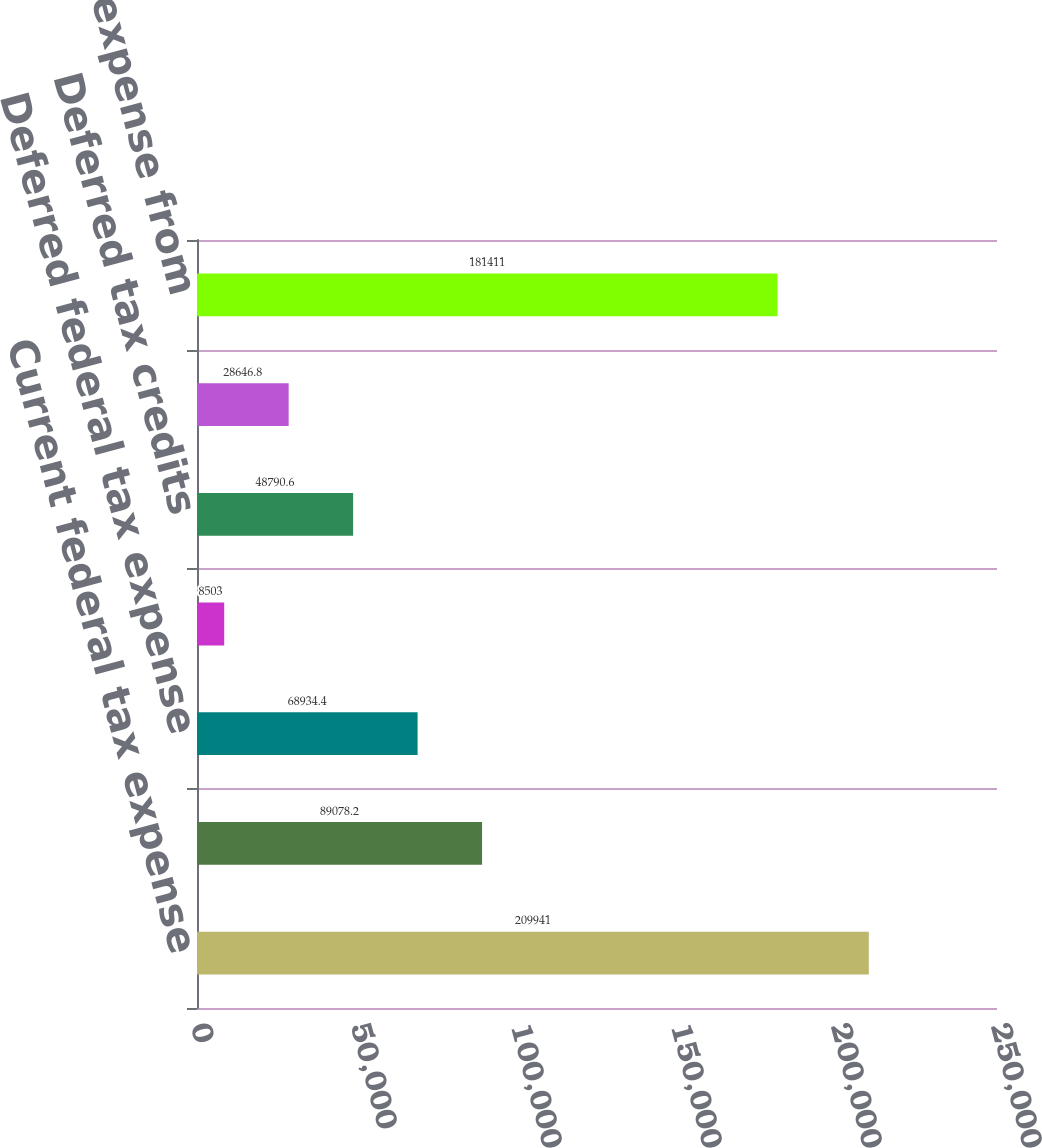<chart> <loc_0><loc_0><loc_500><loc_500><bar_chart><fcel>Current federal tax expense<fcel>Current state tax expense<fcel>Deferred federal tax expense<fcel>Deferred state tax expense<fcel>Deferred tax credits<fcel>Deferred investment tax<fcel>Total income tax expense from<nl><fcel>209941<fcel>89078.2<fcel>68934.4<fcel>8503<fcel>48790.6<fcel>28646.8<fcel>181411<nl></chart> 